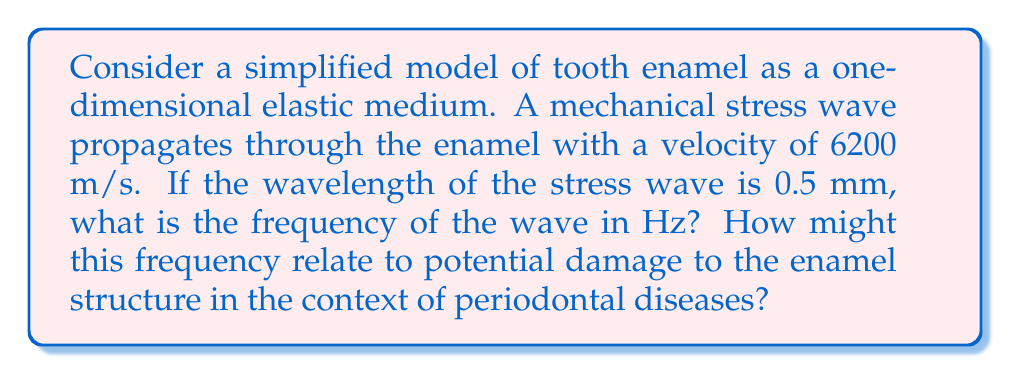Give your solution to this math problem. To solve this problem, we'll use the wave equation and the relationship between wave velocity, frequency, and wavelength.

Step 1: Recall the wave equation
$$v = f \lambda$$
where $v$ is the wave velocity, $f$ is the frequency, and $\lambda$ is the wavelength.

Step 2: Rearrange the equation to solve for frequency
$$f = \frac{v}{\lambda}$$

Step 3: Convert the given values to SI units
Velocity: $v = 6200 \text{ m/s}$
Wavelength: $\lambda = 0.5 \text{ mm} = 0.0005 \text{ m}$

Step 4: Substitute the values into the equation
$$f = \frac{6200 \text{ m/s}}{0.0005 \text{ m}}$$

Step 5: Calculate the frequency
$$f = 12,400,000 \text{ Hz} = 12.4 \text{ MHz}$$

In the context of periodontal diseases, this high-frequency stress wave could potentially relate to:

1. Ultrasonic dental cleaning devices, which operate in the MHz range.
2. Potential resonance effects with bacterial biofilm structures or enamel crystals.
3. Micro-fractures or fatigue in the enamel structure due to repeated high-frequency stress.

Understanding these effects could provide insights into how mechanical stress contributes to enamel degradation in periodontal diseases.
Answer: 12.4 MHz 